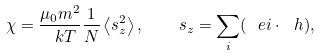<formula> <loc_0><loc_0><loc_500><loc_500>\chi = \frac { \mu _ { 0 } m ^ { 2 } } { \ k T } \frac { 1 } { N } \left \langle s _ { z } ^ { 2 } \right \rangle , \quad s _ { z } = \sum _ { i } ( \ e i \cdot \ h ) ,</formula> 